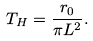Convert formula to latex. <formula><loc_0><loc_0><loc_500><loc_500>T _ { H } = \frac { r _ { 0 } } { \pi L ^ { 2 } } .</formula> 